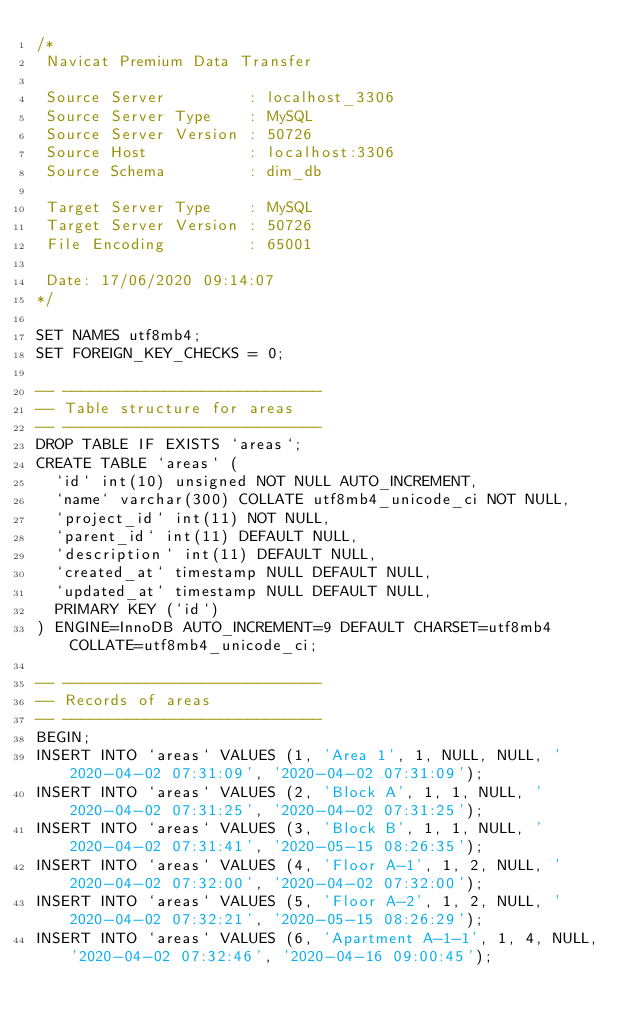Convert code to text. <code><loc_0><loc_0><loc_500><loc_500><_SQL_>/*
 Navicat Premium Data Transfer

 Source Server         : localhost_3306
 Source Server Type    : MySQL
 Source Server Version : 50726
 Source Host           : localhost:3306
 Source Schema         : dim_db

 Target Server Type    : MySQL
 Target Server Version : 50726
 File Encoding         : 65001

 Date: 17/06/2020 09:14:07
*/

SET NAMES utf8mb4;
SET FOREIGN_KEY_CHECKS = 0;

-- ----------------------------
-- Table structure for areas
-- ----------------------------
DROP TABLE IF EXISTS `areas`;
CREATE TABLE `areas` (
  `id` int(10) unsigned NOT NULL AUTO_INCREMENT,
  `name` varchar(300) COLLATE utf8mb4_unicode_ci NOT NULL,
  `project_id` int(11) NOT NULL,
  `parent_id` int(11) DEFAULT NULL,
  `description` int(11) DEFAULT NULL,
  `created_at` timestamp NULL DEFAULT NULL,
  `updated_at` timestamp NULL DEFAULT NULL,
  PRIMARY KEY (`id`)
) ENGINE=InnoDB AUTO_INCREMENT=9 DEFAULT CHARSET=utf8mb4 COLLATE=utf8mb4_unicode_ci;

-- ----------------------------
-- Records of areas
-- ----------------------------
BEGIN;
INSERT INTO `areas` VALUES (1, 'Area 1', 1, NULL, NULL, '2020-04-02 07:31:09', '2020-04-02 07:31:09');
INSERT INTO `areas` VALUES (2, 'Block A', 1, 1, NULL, '2020-04-02 07:31:25', '2020-04-02 07:31:25');
INSERT INTO `areas` VALUES (3, 'Block B', 1, 1, NULL, '2020-04-02 07:31:41', '2020-05-15 08:26:35');
INSERT INTO `areas` VALUES (4, 'Floor A-1', 1, 2, NULL, '2020-04-02 07:32:00', '2020-04-02 07:32:00');
INSERT INTO `areas` VALUES (5, 'Floor A-2', 1, 2, NULL, '2020-04-02 07:32:21', '2020-05-15 08:26:29');
INSERT INTO `areas` VALUES (6, 'Apartment A-1-1', 1, 4, NULL, '2020-04-02 07:32:46', '2020-04-16 09:00:45');</code> 